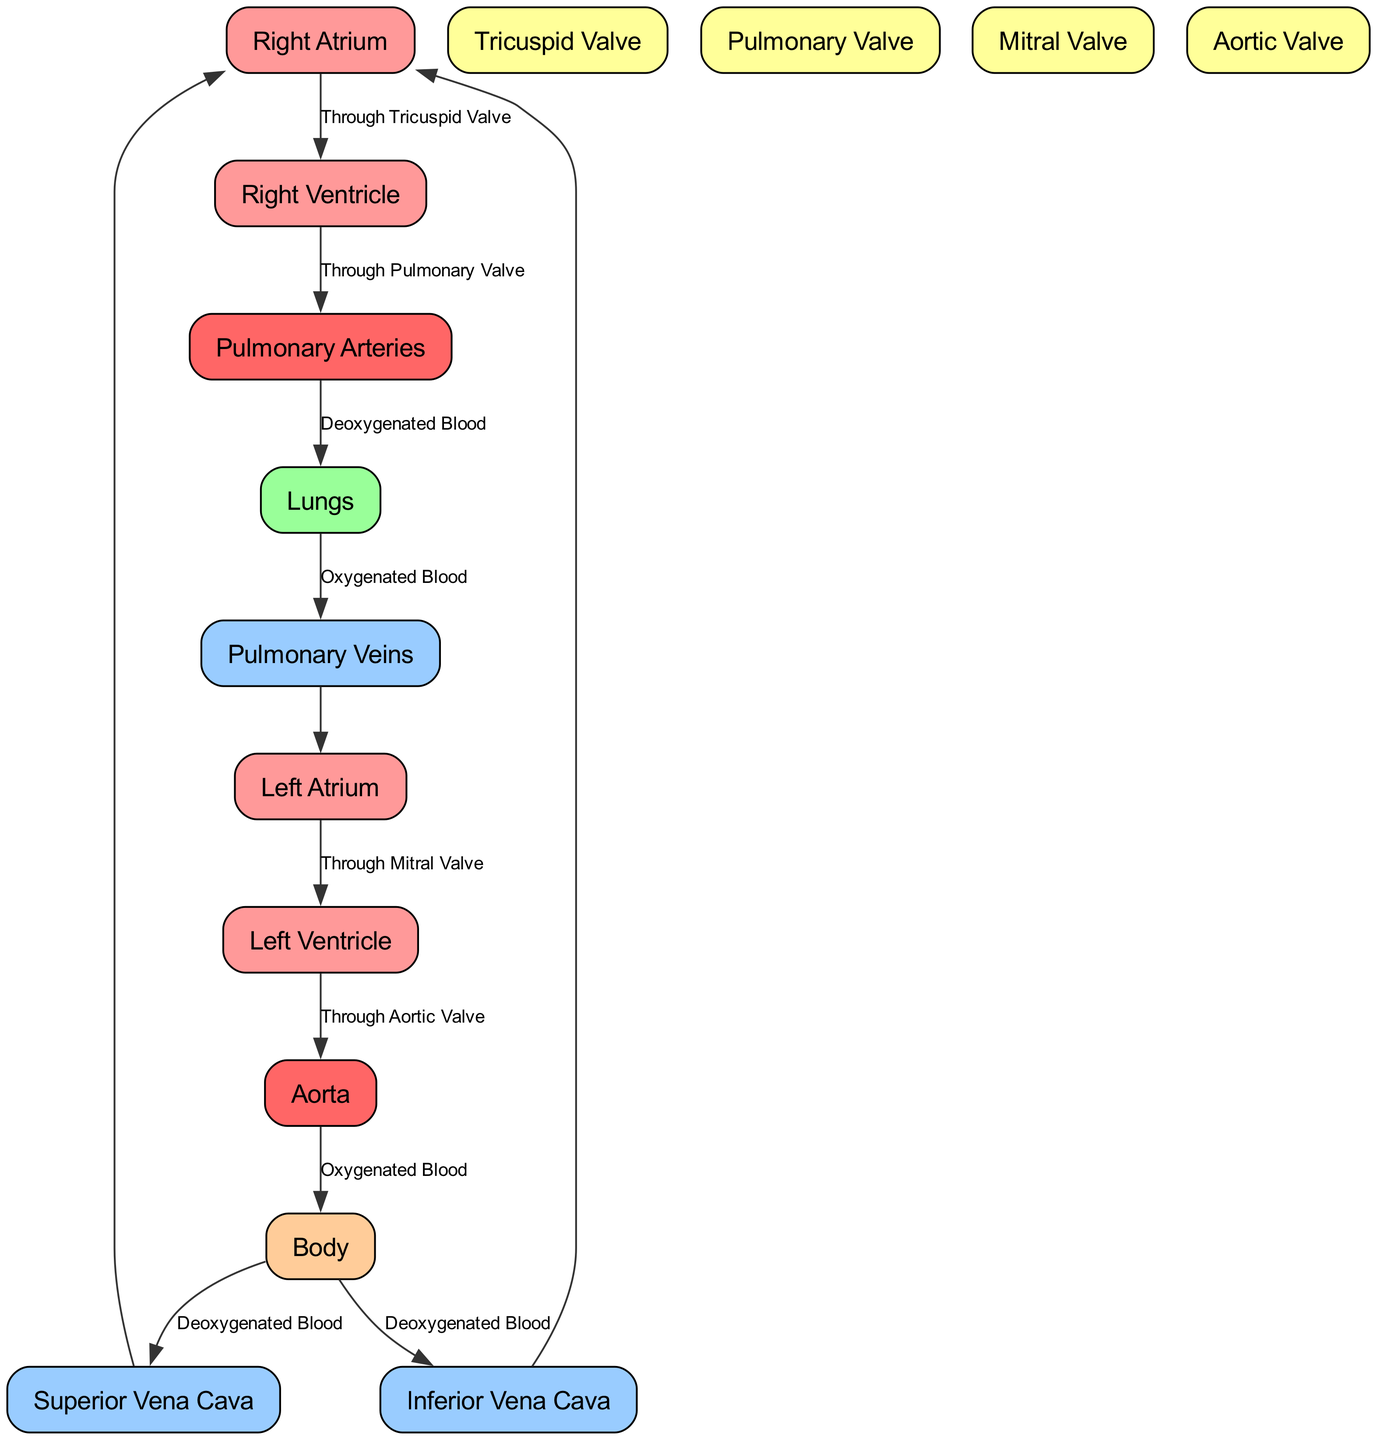What is the last valve blood passes through before it enters the body? The last valve in the flow of blood is the Aortic Valve, as shown by the pathway that goes from the Left Ventricle to the Aorta, which then leads to the body.
Answer: Aortic Valve How many major blood vessels are shown in the diagram? By counting the vessels represented, we find that there are five major blood vessels: Superior Vena Cava, Inferior Vena Cava, Pulmonary Arteries, Pulmonary Veins, and Aorta.
Answer: 5 Which valve allows blood to flow from the right atrium to the right ventricle? The Tricuspid Valve is specifically indicated as the valve that permits this flow, connecting the Right Atrium to the Right Ventricle.
Answer: Tricuspid Valve What type of blood returns to the right atrium from the body? The diagram indicates that the blood returning to the Right Atrium via the Superior and Inferior Vena Cava is deoxygenated, as highlighted in the edges coming from the Body to these vessels.
Answer: Deoxygenated Blood From which part of the cardiovascular system does oxygenated blood travel to reach the left atrium? The pathway shows that oxygenated blood travels from the Lungs through the Pulmonary Veins to reach the Left Atrium.
Answer: Lungs How does blood flow from the left ventricle to the aorta? The flow is through the Aortic Valve, which connects the Left Ventricle to the Aorta as per the diagram's pathways.
Answer: Through Aortic Valve What is the function of the Pulmonary Valve in this system? The Pulmonary Valve functions to regulate blood flow from the Right Ventricle to the Pulmonary Arteries, ensuring that deoxygenated blood is directed towards the lungs for oxygenation.
Answer: Regulates blood flow Identify the area where blood becomes oxygenated in this system. Blood becomes oxygenated within the Lungs, where deoxygenated blood from the Pulmonary Arteries is transformed into oxygenated blood as it traverses through the lung tissue.
Answer: Lungs 